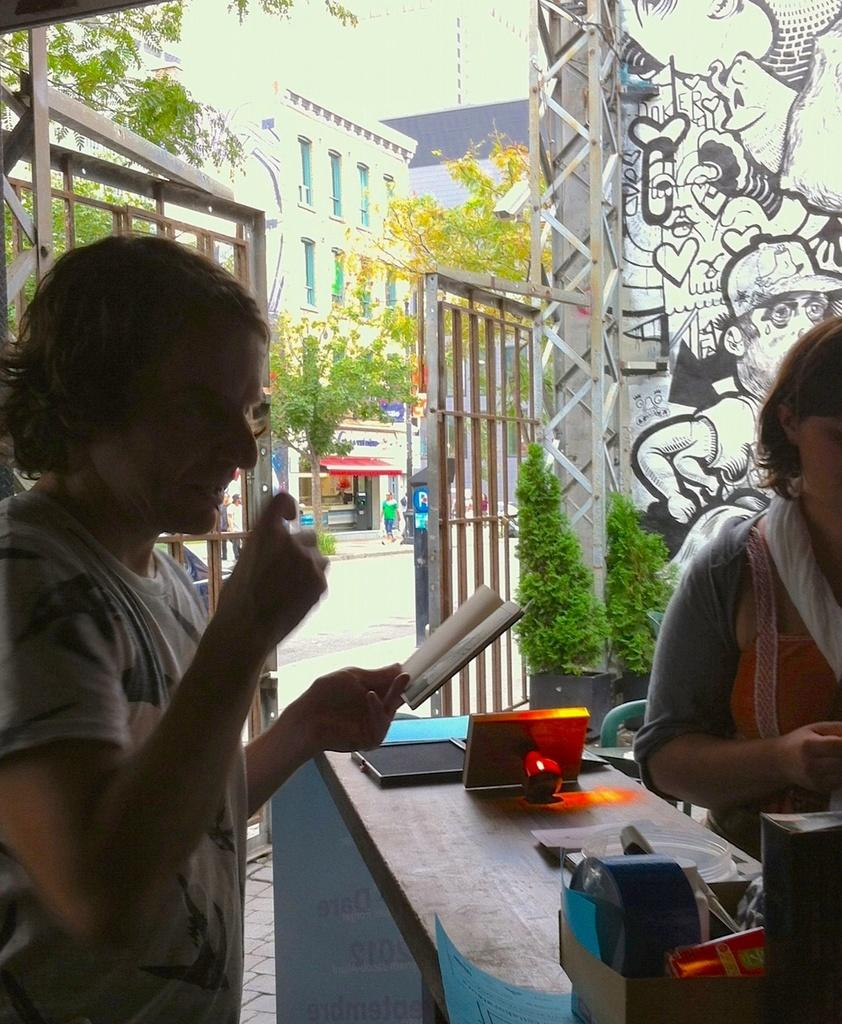What is the woman in the image doing? There is a woman standing at a desk in the image. What is the woman holding in her hand? The woman is holding a small book in her left hand. Can you describe the other person in the image? There is another woman beside the desk in the image. What type of soda is being served in the hall in the image? There is no mention of soda or a hall in the image; it only features a woman standing at a desk and another woman beside the desk. 